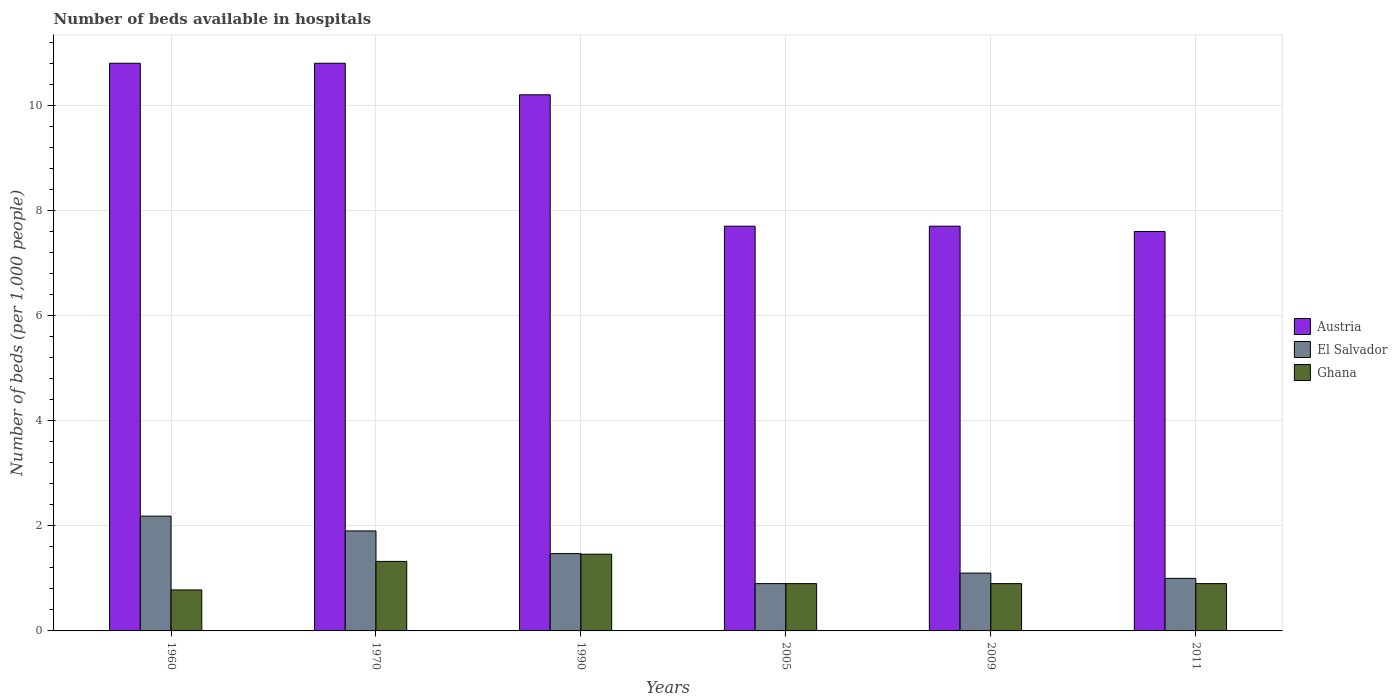How many different coloured bars are there?
Offer a terse response. 3. Are the number of bars on each tick of the X-axis equal?
Your answer should be very brief. Yes. What is the number of beds in the hospiatls of in Austria in 1970?
Provide a succinct answer. 10.8. Across all years, what is the maximum number of beds in the hospiatls of in Ghana?
Give a very brief answer. 1.46. Across all years, what is the minimum number of beds in the hospiatls of in Austria?
Keep it short and to the point. 7.6. In which year was the number of beds in the hospiatls of in El Salvador maximum?
Give a very brief answer. 1960. In which year was the number of beds in the hospiatls of in Austria minimum?
Ensure brevity in your answer.  2011. What is the total number of beds in the hospiatls of in Ghana in the graph?
Make the answer very short. 6.26. What is the difference between the number of beds in the hospiatls of in Ghana in 1960 and that in 2009?
Offer a terse response. -0.12. What is the difference between the number of beds in the hospiatls of in El Salvador in 2011 and the number of beds in the hospiatls of in Ghana in 1960?
Provide a short and direct response. 0.22. What is the average number of beds in the hospiatls of in Austria per year?
Provide a succinct answer. 9.13. In the year 1960, what is the difference between the number of beds in the hospiatls of in El Salvador and number of beds in the hospiatls of in Austria?
Offer a terse response. -8.62. What is the ratio of the number of beds in the hospiatls of in Austria in 1960 to that in 1970?
Make the answer very short. 1. Is the number of beds in the hospiatls of in El Salvador in 2005 less than that in 2009?
Keep it short and to the point. Yes. What is the difference between the highest and the second highest number of beds in the hospiatls of in El Salvador?
Provide a short and direct response. 0.28. What is the difference between the highest and the lowest number of beds in the hospiatls of in El Salvador?
Offer a very short reply. 1.28. Is the sum of the number of beds in the hospiatls of in Ghana in 1960 and 1990 greater than the maximum number of beds in the hospiatls of in El Salvador across all years?
Your answer should be very brief. Yes. How many bars are there?
Provide a succinct answer. 18. How many years are there in the graph?
Your answer should be very brief. 6. Are the values on the major ticks of Y-axis written in scientific E-notation?
Your response must be concise. No. Does the graph contain any zero values?
Offer a terse response. No. Where does the legend appear in the graph?
Offer a very short reply. Center right. How many legend labels are there?
Provide a succinct answer. 3. What is the title of the graph?
Your answer should be very brief. Number of beds available in hospitals. Does "St. Lucia" appear as one of the legend labels in the graph?
Offer a terse response. No. What is the label or title of the X-axis?
Make the answer very short. Years. What is the label or title of the Y-axis?
Your response must be concise. Number of beds (per 1,0 people). What is the Number of beds (per 1,000 people) of Austria in 1960?
Your response must be concise. 10.8. What is the Number of beds (per 1,000 people) of El Salvador in 1960?
Keep it short and to the point. 2.18. What is the Number of beds (per 1,000 people) in Ghana in 1960?
Offer a terse response. 0.78. What is the Number of beds (per 1,000 people) of Austria in 1970?
Keep it short and to the point. 10.8. What is the Number of beds (per 1,000 people) of El Salvador in 1970?
Give a very brief answer. 1.9. What is the Number of beds (per 1,000 people) in Ghana in 1970?
Give a very brief answer. 1.32. What is the Number of beds (per 1,000 people) in Austria in 1990?
Offer a terse response. 10.2. What is the Number of beds (per 1,000 people) of El Salvador in 1990?
Keep it short and to the point. 1.47. What is the Number of beds (per 1,000 people) of Ghana in 1990?
Offer a very short reply. 1.46. What is the Number of beds (per 1,000 people) in Austria in 2009?
Your answer should be very brief. 7.7. What is the Number of beds (per 1,000 people) of Ghana in 2009?
Ensure brevity in your answer.  0.9. What is the Number of beds (per 1,000 people) in Austria in 2011?
Provide a short and direct response. 7.6. What is the Number of beds (per 1,000 people) in Ghana in 2011?
Provide a short and direct response. 0.9. Across all years, what is the maximum Number of beds (per 1,000 people) of Austria?
Make the answer very short. 10.8. Across all years, what is the maximum Number of beds (per 1,000 people) of El Salvador?
Your answer should be compact. 2.18. Across all years, what is the maximum Number of beds (per 1,000 people) of Ghana?
Your answer should be compact. 1.46. Across all years, what is the minimum Number of beds (per 1,000 people) of Austria?
Offer a very short reply. 7.6. Across all years, what is the minimum Number of beds (per 1,000 people) of Ghana?
Keep it short and to the point. 0.78. What is the total Number of beds (per 1,000 people) in Austria in the graph?
Your answer should be very brief. 54.8. What is the total Number of beds (per 1,000 people) of El Salvador in the graph?
Give a very brief answer. 8.56. What is the total Number of beds (per 1,000 people) in Ghana in the graph?
Your response must be concise. 6.26. What is the difference between the Number of beds (per 1,000 people) of Austria in 1960 and that in 1970?
Your response must be concise. 0. What is the difference between the Number of beds (per 1,000 people) in El Salvador in 1960 and that in 1970?
Make the answer very short. 0.28. What is the difference between the Number of beds (per 1,000 people) of Ghana in 1960 and that in 1970?
Your response must be concise. -0.54. What is the difference between the Number of beds (per 1,000 people) of Austria in 1960 and that in 1990?
Offer a terse response. 0.6. What is the difference between the Number of beds (per 1,000 people) of El Salvador in 1960 and that in 1990?
Your answer should be compact. 0.71. What is the difference between the Number of beds (per 1,000 people) of Ghana in 1960 and that in 1990?
Your answer should be compact. -0.68. What is the difference between the Number of beds (per 1,000 people) of El Salvador in 1960 and that in 2005?
Provide a succinct answer. 1.28. What is the difference between the Number of beds (per 1,000 people) in Ghana in 1960 and that in 2005?
Your response must be concise. -0.12. What is the difference between the Number of beds (per 1,000 people) in Austria in 1960 and that in 2009?
Give a very brief answer. 3.1. What is the difference between the Number of beds (per 1,000 people) of El Salvador in 1960 and that in 2009?
Your response must be concise. 1.08. What is the difference between the Number of beds (per 1,000 people) of Ghana in 1960 and that in 2009?
Make the answer very short. -0.12. What is the difference between the Number of beds (per 1,000 people) of Austria in 1960 and that in 2011?
Offer a very short reply. 3.2. What is the difference between the Number of beds (per 1,000 people) in El Salvador in 1960 and that in 2011?
Your answer should be compact. 1.18. What is the difference between the Number of beds (per 1,000 people) in Ghana in 1960 and that in 2011?
Offer a very short reply. -0.12. What is the difference between the Number of beds (per 1,000 people) in Austria in 1970 and that in 1990?
Offer a very short reply. 0.6. What is the difference between the Number of beds (per 1,000 people) of El Salvador in 1970 and that in 1990?
Your answer should be compact. 0.43. What is the difference between the Number of beds (per 1,000 people) in Ghana in 1970 and that in 1990?
Provide a short and direct response. -0.14. What is the difference between the Number of beds (per 1,000 people) of Austria in 1970 and that in 2005?
Give a very brief answer. 3.1. What is the difference between the Number of beds (per 1,000 people) in El Salvador in 1970 and that in 2005?
Make the answer very short. 1. What is the difference between the Number of beds (per 1,000 people) of Ghana in 1970 and that in 2005?
Offer a terse response. 0.42. What is the difference between the Number of beds (per 1,000 people) of Austria in 1970 and that in 2009?
Give a very brief answer. 3.1. What is the difference between the Number of beds (per 1,000 people) of El Salvador in 1970 and that in 2009?
Your response must be concise. 0.8. What is the difference between the Number of beds (per 1,000 people) of Ghana in 1970 and that in 2009?
Provide a short and direct response. 0.42. What is the difference between the Number of beds (per 1,000 people) in Austria in 1970 and that in 2011?
Your answer should be very brief. 3.2. What is the difference between the Number of beds (per 1,000 people) in El Salvador in 1970 and that in 2011?
Keep it short and to the point. 0.9. What is the difference between the Number of beds (per 1,000 people) of Ghana in 1970 and that in 2011?
Your response must be concise. 0.42. What is the difference between the Number of beds (per 1,000 people) of Austria in 1990 and that in 2005?
Offer a terse response. 2.5. What is the difference between the Number of beds (per 1,000 people) in El Salvador in 1990 and that in 2005?
Offer a very short reply. 0.57. What is the difference between the Number of beds (per 1,000 people) of Ghana in 1990 and that in 2005?
Your response must be concise. 0.56. What is the difference between the Number of beds (per 1,000 people) in El Salvador in 1990 and that in 2009?
Keep it short and to the point. 0.37. What is the difference between the Number of beds (per 1,000 people) in Ghana in 1990 and that in 2009?
Your answer should be compact. 0.56. What is the difference between the Number of beds (per 1,000 people) of El Salvador in 1990 and that in 2011?
Offer a terse response. 0.47. What is the difference between the Number of beds (per 1,000 people) of Ghana in 1990 and that in 2011?
Your answer should be compact. 0.56. What is the difference between the Number of beds (per 1,000 people) of Austria in 2005 and that in 2009?
Your answer should be very brief. 0. What is the difference between the Number of beds (per 1,000 people) of Austria in 2005 and that in 2011?
Give a very brief answer. 0.1. What is the difference between the Number of beds (per 1,000 people) of Austria in 1960 and the Number of beds (per 1,000 people) of El Salvador in 1970?
Your answer should be very brief. 8.9. What is the difference between the Number of beds (per 1,000 people) of Austria in 1960 and the Number of beds (per 1,000 people) of Ghana in 1970?
Your answer should be very brief. 9.48. What is the difference between the Number of beds (per 1,000 people) in El Salvador in 1960 and the Number of beds (per 1,000 people) in Ghana in 1970?
Give a very brief answer. 0.86. What is the difference between the Number of beds (per 1,000 people) of Austria in 1960 and the Number of beds (per 1,000 people) of El Salvador in 1990?
Your answer should be compact. 9.33. What is the difference between the Number of beds (per 1,000 people) in Austria in 1960 and the Number of beds (per 1,000 people) in Ghana in 1990?
Your answer should be compact. 9.34. What is the difference between the Number of beds (per 1,000 people) in El Salvador in 1960 and the Number of beds (per 1,000 people) in Ghana in 1990?
Ensure brevity in your answer.  0.72. What is the difference between the Number of beds (per 1,000 people) in Austria in 1960 and the Number of beds (per 1,000 people) in El Salvador in 2005?
Provide a short and direct response. 9.9. What is the difference between the Number of beds (per 1,000 people) in El Salvador in 1960 and the Number of beds (per 1,000 people) in Ghana in 2005?
Provide a succinct answer. 1.28. What is the difference between the Number of beds (per 1,000 people) in Austria in 1960 and the Number of beds (per 1,000 people) in El Salvador in 2009?
Provide a short and direct response. 9.7. What is the difference between the Number of beds (per 1,000 people) in El Salvador in 1960 and the Number of beds (per 1,000 people) in Ghana in 2009?
Provide a short and direct response. 1.28. What is the difference between the Number of beds (per 1,000 people) in El Salvador in 1960 and the Number of beds (per 1,000 people) in Ghana in 2011?
Keep it short and to the point. 1.28. What is the difference between the Number of beds (per 1,000 people) in Austria in 1970 and the Number of beds (per 1,000 people) in El Salvador in 1990?
Your answer should be compact. 9.33. What is the difference between the Number of beds (per 1,000 people) in Austria in 1970 and the Number of beds (per 1,000 people) in Ghana in 1990?
Your answer should be compact. 9.34. What is the difference between the Number of beds (per 1,000 people) of El Salvador in 1970 and the Number of beds (per 1,000 people) of Ghana in 1990?
Provide a short and direct response. 0.44. What is the difference between the Number of beds (per 1,000 people) of Austria in 1970 and the Number of beds (per 1,000 people) of El Salvador in 2005?
Your answer should be very brief. 9.9. What is the difference between the Number of beds (per 1,000 people) of Austria in 1970 and the Number of beds (per 1,000 people) of El Salvador in 2009?
Your response must be concise. 9.7. What is the difference between the Number of beds (per 1,000 people) in Austria in 1970 and the Number of beds (per 1,000 people) in Ghana in 2011?
Provide a short and direct response. 9.9. What is the difference between the Number of beds (per 1,000 people) in El Salvador in 1970 and the Number of beds (per 1,000 people) in Ghana in 2011?
Provide a short and direct response. 1. What is the difference between the Number of beds (per 1,000 people) of Austria in 1990 and the Number of beds (per 1,000 people) of El Salvador in 2005?
Your answer should be compact. 9.3. What is the difference between the Number of beds (per 1,000 people) in El Salvador in 1990 and the Number of beds (per 1,000 people) in Ghana in 2005?
Offer a very short reply. 0.57. What is the difference between the Number of beds (per 1,000 people) of Austria in 1990 and the Number of beds (per 1,000 people) of Ghana in 2009?
Ensure brevity in your answer.  9.3. What is the difference between the Number of beds (per 1,000 people) in El Salvador in 1990 and the Number of beds (per 1,000 people) in Ghana in 2009?
Provide a succinct answer. 0.57. What is the difference between the Number of beds (per 1,000 people) of Austria in 1990 and the Number of beds (per 1,000 people) of Ghana in 2011?
Provide a succinct answer. 9.3. What is the difference between the Number of beds (per 1,000 people) in El Salvador in 1990 and the Number of beds (per 1,000 people) in Ghana in 2011?
Ensure brevity in your answer.  0.57. What is the difference between the Number of beds (per 1,000 people) in Austria in 2005 and the Number of beds (per 1,000 people) in Ghana in 2009?
Your answer should be compact. 6.8. What is the difference between the Number of beds (per 1,000 people) in El Salvador in 2005 and the Number of beds (per 1,000 people) in Ghana in 2009?
Keep it short and to the point. 0. What is the difference between the Number of beds (per 1,000 people) of Austria in 2005 and the Number of beds (per 1,000 people) of Ghana in 2011?
Your answer should be very brief. 6.8. What is the difference between the Number of beds (per 1,000 people) of El Salvador in 2005 and the Number of beds (per 1,000 people) of Ghana in 2011?
Make the answer very short. 0. What is the difference between the Number of beds (per 1,000 people) of Austria in 2009 and the Number of beds (per 1,000 people) of El Salvador in 2011?
Provide a succinct answer. 6.7. What is the difference between the Number of beds (per 1,000 people) in Austria in 2009 and the Number of beds (per 1,000 people) in Ghana in 2011?
Your answer should be very brief. 6.8. What is the difference between the Number of beds (per 1,000 people) of El Salvador in 2009 and the Number of beds (per 1,000 people) of Ghana in 2011?
Your answer should be compact. 0.2. What is the average Number of beds (per 1,000 people) in Austria per year?
Your response must be concise. 9.13. What is the average Number of beds (per 1,000 people) in El Salvador per year?
Offer a very short reply. 1.43. What is the average Number of beds (per 1,000 people) in Ghana per year?
Your response must be concise. 1.04. In the year 1960, what is the difference between the Number of beds (per 1,000 people) in Austria and Number of beds (per 1,000 people) in El Salvador?
Keep it short and to the point. 8.62. In the year 1960, what is the difference between the Number of beds (per 1,000 people) in Austria and Number of beds (per 1,000 people) in Ghana?
Offer a very short reply. 10.02. In the year 1960, what is the difference between the Number of beds (per 1,000 people) of El Salvador and Number of beds (per 1,000 people) of Ghana?
Provide a short and direct response. 1.4. In the year 1970, what is the difference between the Number of beds (per 1,000 people) in Austria and Number of beds (per 1,000 people) in El Salvador?
Offer a terse response. 8.9. In the year 1970, what is the difference between the Number of beds (per 1,000 people) in Austria and Number of beds (per 1,000 people) in Ghana?
Ensure brevity in your answer.  9.48. In the year 1970, what is the difference between the Number of beds (per 1,000 people) in El Salvador and Number of beds (per 1,000 people) in Ghana?
Keep it short and to the point. 0.58. In the year 1990, what is the difference between the Number of beds (per 1,000 people) of Austria and Number of beds (per 1,000 people) of El Salvador?
Give a very brief answer. 8.73. In the year 1990, what is the difference between the Number of beds (per 1,000 people) of Austria and Number of beds (per 1,000 people) of Ghana?
Keep it short and to the point. 8.74. In the year 1990, what is the difference between the Number of beds (per 1,000 people) of El Salvador and Number of beds (per 1,000 people) of Ghana?
Offer a terse response. 0.01. In the year 2005, what is the difference between the Number of beds (per 1,000 people) of Austria and Number of beds (per 1,000 people) of El Salvador?
Give a very brief answer. 6.8. In the year 2009, what is the difference between the Number of beds (per 1,000 people) in Austria and Number of beds (per 1,000 people) in El Salvador?
Offer a very short reply. 6.6. In the year 2009, what is the difference between the Number of beds (per 1,000 people) in Austria and Number of beds (per 1,000 people) in Ghana?
Provide a short and direct response. 6.8. What is the ratio of the Number of beds (per 1,000 people) in Austria in 1960 to that in 1970?
Provide a succinct answer. 1. What is the ratio of the Number of beds (per 1,000 people) of El Salvador in 1960 to that in 1970?
Your response must be concise. 1.15. What is the ratio of the Number of beds (per 1,000 people) in Ghana in 1960 to that in 1970?
Your answer should be compact. 0.59. What is the ratio of the Number of beds (per 1,000 people) of Austria in 1960 to that in 1990?
Ensure brevity in your answer.  1.06. What is the ratio of the Number of beds (per 1,000 people) in El Salvador in 1960 to that in 1990?
Make the answer very short. 1.48. What is the ratio of the Number of beds (per 1,000 people) in Ghana in 1960 to that in 1990?
Your answer should be compact. 0.53. What is the ratio of the Number of beds (per 1,000 people) in Austria in 1960 to that in 2005?
Give a very brief answer. 1.4. What is the ratio of the Number of beds (per 1,000 people) in El Salvador in 1960 to that in 2005?
Make the answer very short. 2.43. What is the ratio of the Number of beds (per 1,000 people) in Ghana in 1960 to that in 2005?
Keep it short and to the point. 0.87. What is the ratio of the Number of beds (per 1,000 people) of Austria in 1960 to that in 2009?
Provide a short and direct response. 1.4. What is the ratio of the Number of beds (per 1,000 people) in El Salvador in 1960 to that in 2009?
Give a very brief answer. 1.99. What is the ratio of the Number of beds (per 1,000 people) of Ghana in 1960 to that in 2009?
Ensure brevity in your answer.  0.87. What is the ratio of the Number of beds (per 1,000 people) of Austria in 1960 to that in 2011?
Your answer should be compact. 1.42. What is the ratio of the Number of beds (per 1,000 people) of El Salvador in 1960 to that in 2011?
Give a very brief answer. 2.18. What is the ratio of the Number of beds (per 1,000 people) in Ghana in 1960 to that in 2011?
Make the answer very short. 0.87. What is the ratio of the Number of beds (per 1,000 people) of Austria in 1970 to that in 1990?
Provide a short and direct response. 1.06. What is the ratio of the Number of beds (per 1,000 people) in El Salvador in 1970 to that in 1990?
Your answer should be very brief. 1.29. What is the ratio of the Number of beds (per 1,000 people) in Ghana in 1970 to that in 1990?
Your answer should be very brief. 0.91. What is the ratio of the Number of beds (per 1,000 people) in Austria in 1970 to that in 2005?
Provide a short and direct response. 1.4. What is the ratio of the Number of beds (per 1,000 people) of El Salvador in 1970 to that in 2005?
Give a very brief answer. 2.11. What is the ratio of the Number of beds (per 1,000 people) in Ghana in 1970 to that in 2005?
Provide a succinct answer. 1.47. What is the ratio of the Number of beds (per 1,000 people) of Austria in 1970 to that in 2009?
Ensure brevity in your answer.  1.4. What is the ratio of the Number of beds (per 1,000 people) in El Salvador in 1970 to that in 2009?
Your answer should be very brief. 1.73. What is the ratio of the Number of beds (per 1,000 people) in Ghana in 1970 to that in 2009?
Offer a terse response. 1.47. What is the ratio of the Number of beds (per 1,000 people) in Austria in 1970 to that in 2011?
Your answer should be very brief. 1.42. What is the ratio of the Number of beds (per 1,000 people) in El Salvador in 1970 to that in 2011?
Make the answer very short. 1.9. What is the ratio of the Number of beds (per 1,000 people) in Ghana in 1970 to that in 2011?
Your answer should be very brief. 1.47. What is the ratio of the Number of beds (per 1,000 people) of Austria in 1990 to that in 2005?
Provide a succinct answer. 1.32. What is the ratio of the Number of beds (per 1,000 people) in El Salvador in 1990 to that in 2005?
Make the answer very short. 1.63. What is the ratio of the Number of beds (per 1,000 people) in Ghana in 1990 to that in 2005?
Keep it short and to the point. 1.62. What is the ratio of the Number of beds (per 1,000 people) in Austria in 1990 to that in 2009?
Give a very brief answer. 1.32. What is the ratio of the Number of beds (per 1,000 people) in El Salvador in 1990 to that in 2009?
Give a very brief answer. 1.34. What is the ratio of the Number of beds (per 1,000 people) in Ghana in 1990 to that in 2009?
Offer a very short reply. 1.62. What is the ratio of the Number of beds (per 1,000 people) in Austria in 1990 to that in 2011?
Your answer should be compact. 1.34. What is the ratio of the Number of beds (per 1,000 people) of El Salvador in 1990 to that in 2011?
Provide a succinct answer. 1.47. What is the ratio of the Number of beds (per 1,000 people) in Ghana in 1990 to that in 2011?
Your response must be concise. 1.62. What is the ratio of the Number of beds (per 1,000 people) in El Salvador in 2005 to that in 2009?
Provide a succinct answer. 0.82. What is the ratio of the Number of beds (per 1,000 people) in Austria in 2005 to that in 2011?
Provide a succinct answer. 1.01. What is the ratio of the Number of beds (per 1,000 people) of Ghana in 2005 to that in 2011?
Make the answer very short. 1. What is the ratio of the Number of beds (per 1,000 people) in Austria in 2009 to that in 2011?
Ensure brevity in your answer.  1.01. What is the ratio of the Number of beds (per 1,000 people) of El Salvador in 2009 to that in 2011?
Offer a very short reply. 1.1. What is the difference between the highest and the second highest Number of beds (per 1,000 people) in El Salvador?
Ensure brevity in your answer.  0.28. What is the difference between the highest and the second highest Number of beds (per 1,000 people) in Ghana?
Your answer should be very brief. 0.14. What is the difference between the highest and the lowest Number of beds (per 1,000 people) in El Salvador?
Your response must be concise. 1.28. What is the difference between the highest and the lowest Number of beds (per 1,000 people) in Ghana?
Offer a terse response. 0.68. 